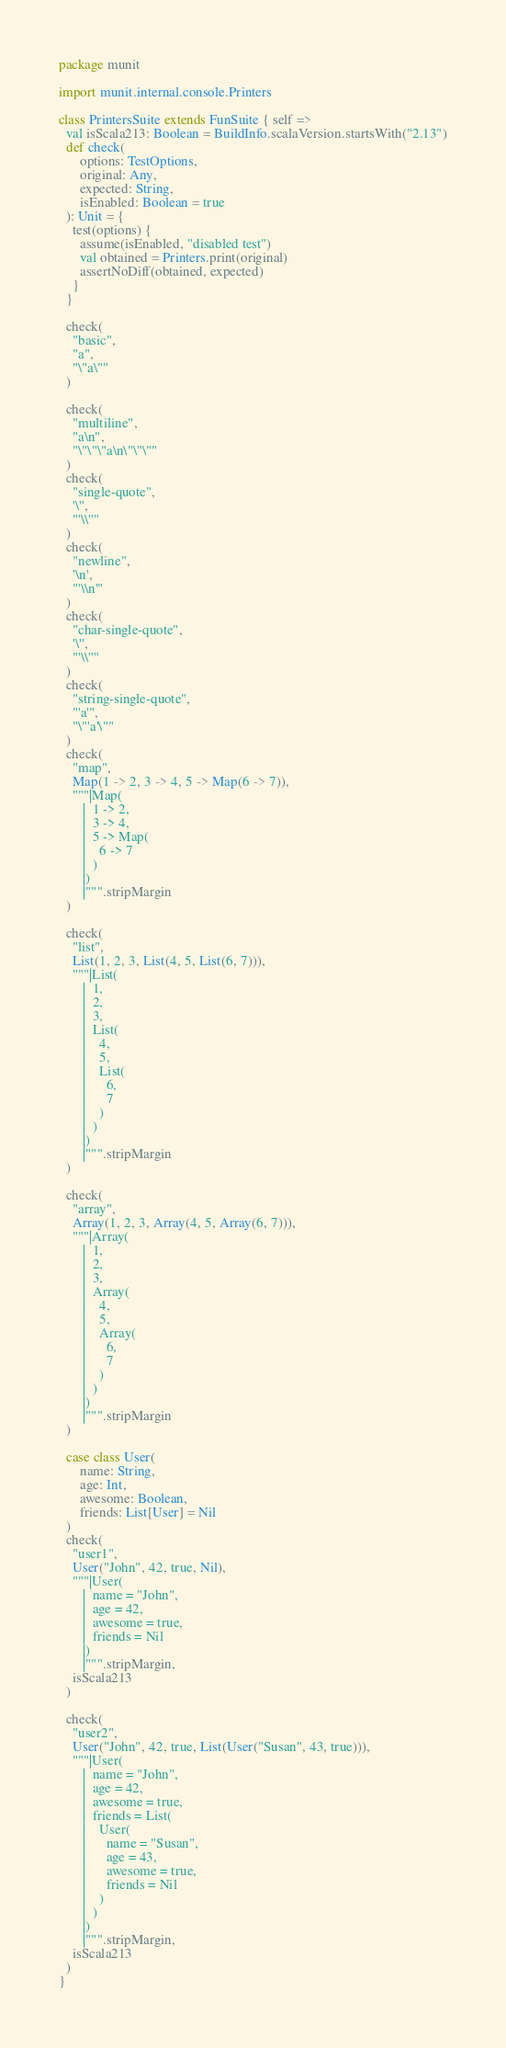Convert code to text. <code><loc_0><loc_0><loc_500><loc_500><_Scala_>package munit

import munit.internal.console.Printers

class PrintersSuite extends FunSuite { self =>
  val isScala213: Boolean = BuildInfo.scalaVersion.startsWith("2.13")
  def check(
      options: TestOptions,
      original: Any,
      expected: String,
      isEnabled: Boolean = true
  ): Unit = {
    test(options) {
      assume(isEnabled, "disabled test")
      val obtained = Printers.print(original)
      assertNoDiff(obtained, expected)
    }
  }

  check(
    "basic",
    "a",
    "\"a\""
  )

  check(
    "multiline",
    "a\n",
    "\"\"\"a\n\"\"\""
  )
  check(
    "single-quote",
    '\'',
    "'\\''"
  )
  check(
    "newline",
    '\n',
    "'\\n'"
  )
  check(
    "char-single-quote",
    '\'',
    "'\\''"
  )
  check(
    "string-single-quote",
    "'a'",
    "\"'a'\""
  )
  check(
    "map",
    Map(1 -> 2, 3 -> 4, 5 -> Map(6 -> 7)),
    """|Map(
       |  1 -> 2,
       |  3 -> 4,
       |  5 -> Map(
       |    6 -> 7
       |  )
       |)
       |""".stripMargin
  )

  check(
    "list",
    List(1, 2, 3, List(4, 5, List(6, 7))),
    """|List(
       |  1,
       |  2,
       |  3,
       |  List(
       |    4,
       |    5,
       |    List(
       |      6,
       |      7
       |    )
       |  )
       |)
       |""".stripMargin
  )

  check(
    "array",
    Array(1, 2, 3, Array(4, 5, Array(6, 7))),
    """|Array(
       |  1,
       |  2,
       |  3,
       |  Array(
       |    4,
       |    5,
       |    Array(
       |      6,
       |      7
       |    )
       |  )
       |)
       |""".stripMargin
  )

  case class User(
      name: String,
      age: Int,
      awesome: Boolean,
      friends: List[User] = Nil
  )
  check(
    "user1",
    User("John", 42, true, Nil),
    """|User(
       |  name = "John",
       |  age = 42,
       |  awesome = true,
       |  friends = Nil
       |)
       |""".stripMargin,
    isScala213
  )

  check(
    "user2",
    User("John", 42, true, List(User("Susan", 43, true))),
    """|User(
       |  name = "John",
       |  age = 42,
       |  awesome = true,
       |  friends = List(
       |    User(
       |      name = "Susan",
       |      age = 43,
       |      awesome = true,
       |      friends = Nil
       |    )
       |  )
       |)
       |""".stripMargin,
    isScala213
  )
}
</code> 